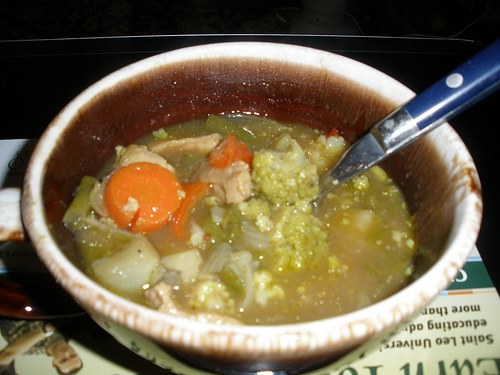How would you describe the taste of this soup? The soup likely has a rich, savory taste with a hint of sweetness from the carrots and onions. The broccoli adds a slightly bitter note, and the tender meat provides a hearty, umami flavor. The broth is warm and comforting, possibly seasoned with a hint of herbs like thyme or bay leaf to add depth to the overall flavor profile. 